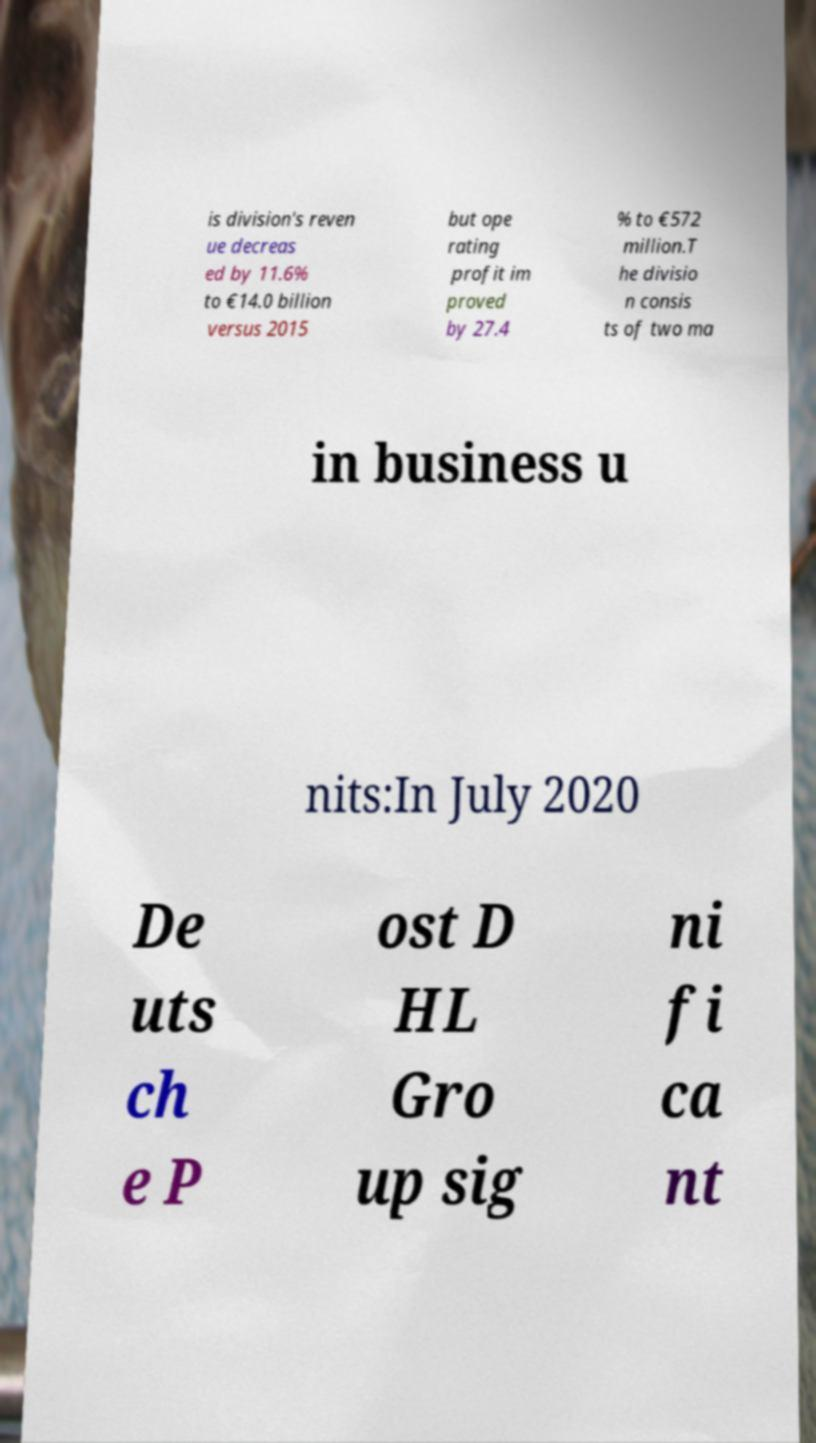Please identify and transcribe the text found in this image. is division's reven ue decreas ed by 11.6% to €14.0 billion versus 2015 but ope rating profit im proved by 27.4 % to €572 million.T he divisio n consis ts of two ma in business u nits:In July 2020 De uts ch e P ost D HL Gro up sig ni fi ca nt 